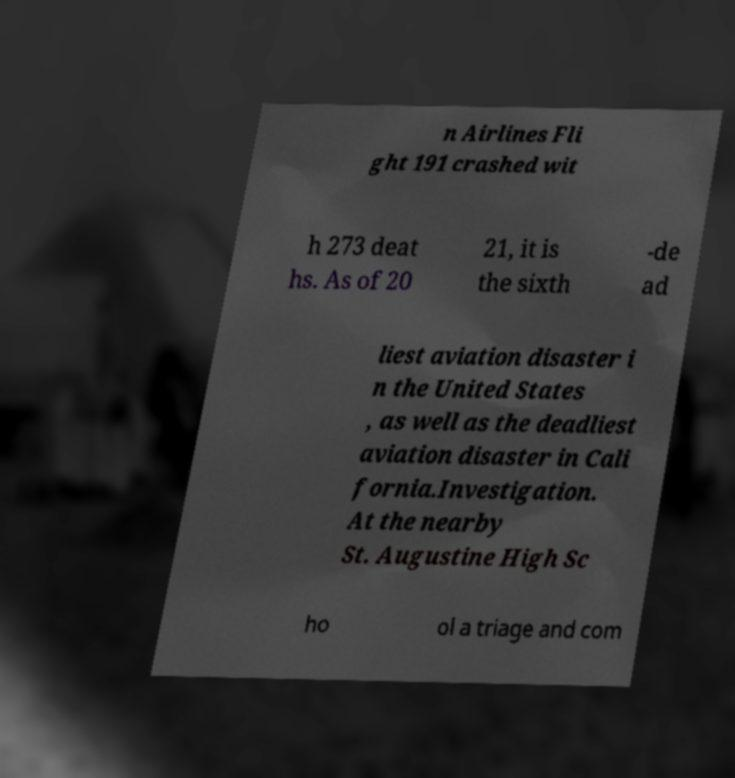I need the written content from this picture converted into text. Can you do that? n Airlines Fli ght 191 crashed wit h 273 deat hs. As of 20 21, it is the sixth -de ad liest aviation disaster i n the United States , as well as the deadliest aviation disaster in Cali fornia.Investigation. At the nearby St. Augustine High Sc ho ol a triage and com 